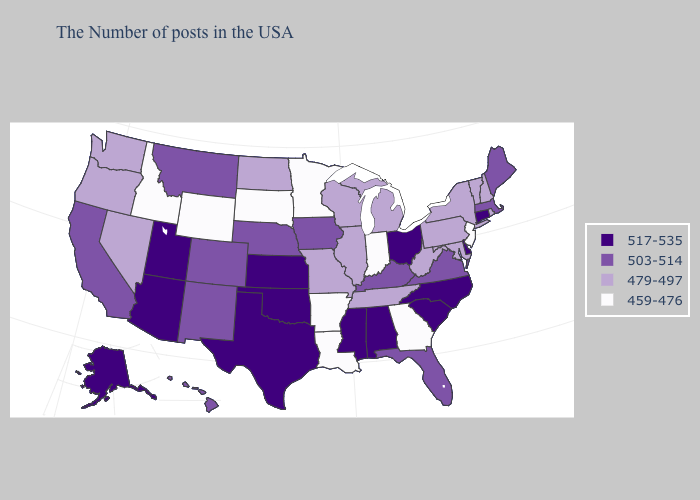What is the highest value in the USA?
Short answer required. 517-535. Which states hav the highest value in the Northeast?
Quick response, please. Connecticut. Name the states that have a value in the range 503-514?
Short answer required. Maine, Massachusetts, Virginia, Florida, Kentucky, Iowa, Nebraska, Colorado, New Mexico, Montana, California, Hawaii. Among the states that border North Carolina , does South Carolina have the highest value?
Keep it brief. Yes. Does New Jersey have the lowest value in the USA?
Quick response, please. Yes. Among the states that border Rhode Island , does Massachusetts have the highest value?
Answer briefly. No. Name the states that have a value in the range 503-514?
Quick response, please. Maine, Massachusetts, Virginia, Florida, Kentucky, Iowa, Nebraska, Colorado, New Mexico, Montana, California, Hawaii. Name the states that have a value in the range 479-497?
Concise answer only. Rhode Island, New Hampshire, Vermont, New York, Maryland, Pennsylvania, West Virginia, Michigan, Tennessee, Wisconsin, Illinois, Missouri, North Dakota, Nevada, Washington, Oregon. Does Massachusetts have a higher value than Iowa?
Be succinct. No. What is the value of North Dakota?
Keep it brief. 479-497. Which states have the highest value in the USA?
Be succinct. Connecticut, Delaware, North Carolina, South Carolina, Ohio, Alabama, Mississippi, Kansas, Oklahoma, Texas, Utah, Arizona, Alaska. What is the highest value in the South ?
Keep it brief. 517-535. Among the states that border Utah , does Arizona have the highest value?
Keep it brief. Yes. Does Kansas have the same value as New York?
Concise answer only. No. Which states hav the highest value in the West?
Short answer required. Utah, Arizona, Alaska. 